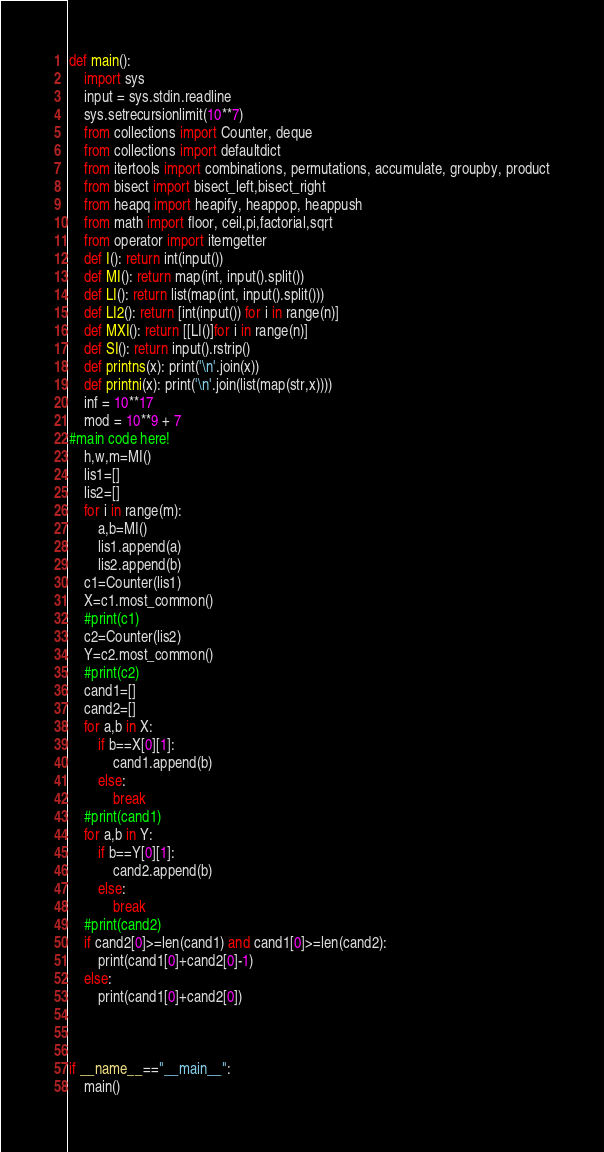Convert code to text. <code><loc_0><loc_0><loc_500><loc_500><_Python_>def main():
    import sys
    input = sys.stdin.readline
    sys.setrecursionlimit(10**7)
    from collections import Counter, deque
    from collections import defaultdict
    from itertools import combinations, permutations, accumulate, groupby, product
    from bisect import bisect_left,bisect_right
    from heapq import heapify, heappop, heappush
    from math import floor, ceil,pi,factorial,sqrt
    from operator import itemgetter
    def I(): return int(input())
    def MI(): return map(int, input().split())
    def LI(): return list(map(int, input().split()))
    def LI2(): return [int(input()) for i in range(n)]
    def MXI(): return [[LI()]for i in range(n)]
    def SI(): return input().rstrip()
    def printns(x): print('\n'.join(x))
    def printni(x): print('\n'.join(list(map(str,x))))
    inf = 10**17
    mod = 10**9 + 7
#main code here!
    h,w,m=MI()
    lis1=[]
    lis2=[]
    for i in range(m):
        a,b=MI()
        lis1.append(a)
        lis2.append(b)
    c1=Counter(lis1)
    X=c1.most_common()
    #print(c1)
    c2=Counter(lis2)
    Y=c2.most_common()
    #print(c2)
    cand1=[]
    cand2=[]
    for a,b in X:
        if b==X[0][1]:
            cand1.append(b)
        else:
            break
    #print(cand1)
    for a,b in Y:
        if b==Y[0][1]:
            cand2.append(b)
        else:
            break
    #print(cand2)
    if cand2[0]>=len(cand1) and cand1[0]>=len(cand2):
        print(cand1[0]+cand2[0]-1)
    else:
        print(cand1[0]+cand2[0])
            
    

if __name__=="__main__":
    main()

</code> 